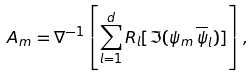Convert formula to latex. <formula><loc_0><loc_0><loc_500><loc_500>A _ { m } = \nabla ^ { - 1 } \left [ \sum _ { l = 1 } ^ { d } R _ { l } [ \Im ( \psi _ { m } \, \overline { \psi } _ { l } ) ] \right ] ,</formula> 